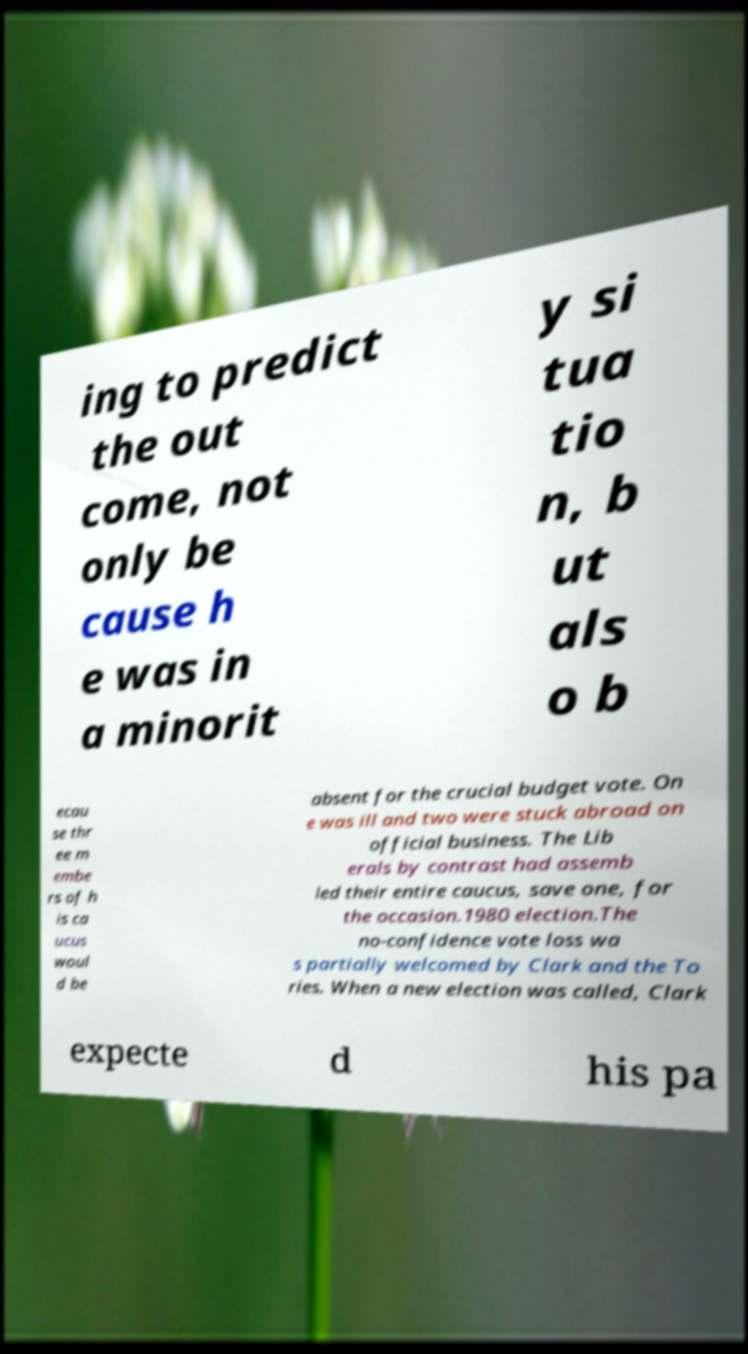Can you accurately transcribe the text from the provided image for me? ing to predict the out come, not only be cause h e was in a minorit y si tua tio n, b ut als o b ecau se thr ee m embe rs of h is ca ucus woul d be absent for the crucial budget vote. On e was ill and two were stuck abroad on official business. The Lib erals by contrast had assemb led their entire caucus, save one, for the occasion.1980 election.The no-confidence vote loss wa s partially welcomed by Clark and the To ries. When a new election was called, Clark expecte d his pa 